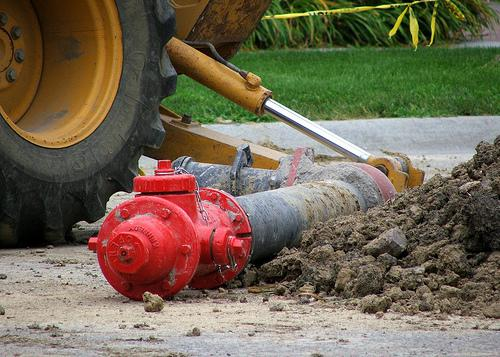Question: what color is the dirt?
Choices:
A. Black.
B. Gray.
C. White.
D. Brown.
Answer with the letter. Answer: D Question: where did the hydrant come from?
Choices:
A. The ground.
B. Firemean.
C. Hose connection.
D. Street.
Answer with the letter. Answer: A Question: why is the hydrant on its side?
Choices:
A. Fell over.
B. Hit.
C. Being installed.
D. It was dug up.
Answer with the letter. Answer: D Question: what color is the truck?
Choices:
A. Red.
B. Yellow.
C. Black.
D. Blue.
Answer with the letter. Answer: B 